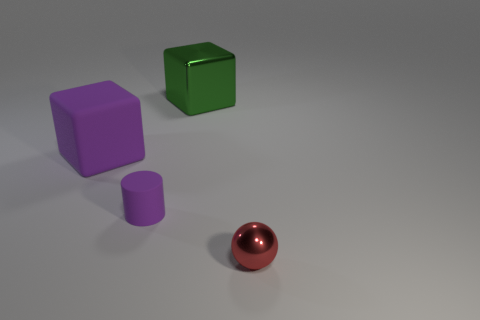Add 2 big gray objects. How many objects exist? 6 Subtract all cylinders. How many objects are left? 3 Add 3 big blocks. How many big blocks are left? 5 Add 1 small cylinders. How many small cylinders exist? 2 Subtract 0 gray cubes. How many objects are left? 4 Subtract all tiny cylinders. Subtract all purple blocks. How many objects are left? 2 